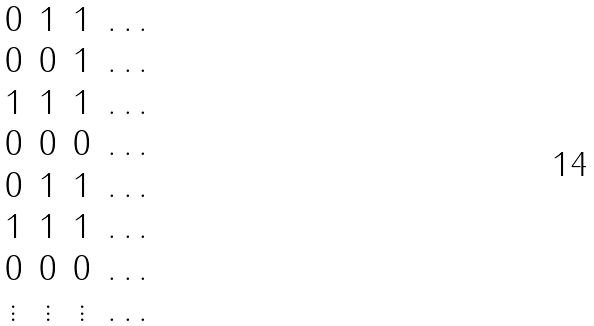<formula> <loc_0><loc_0><loc_500><loc_500>\begin{matrix} 0 & 1 & 1 & \dots \\ 0 & 0 & 1 & \dots \\ 1 & 1 & 1 & \dots \\ 0 & 0 & 0 & \dots \\ 0 & 1 & 1 & \dots \\ 1 & 1 & 1 & \dots \\ 0 & 0 & 0 & \dots \\ \vdots & \vdots & \vdots & \dots \end{matrix}</formula> 